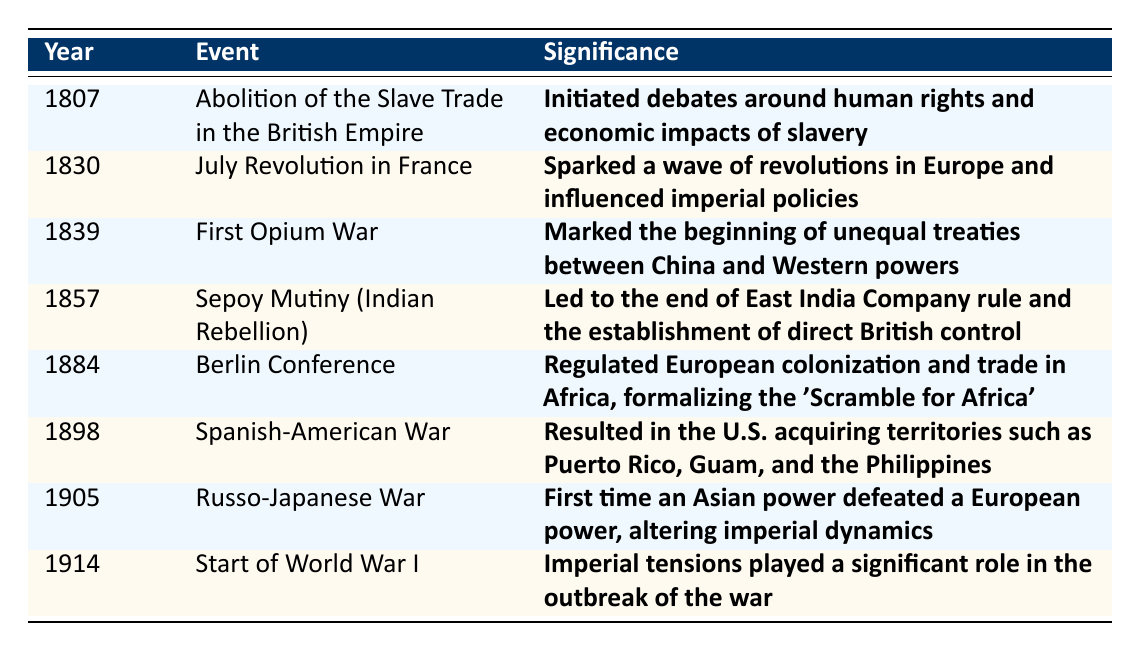What year did the Abolition of the Slave Trade in the British Empire occur? The table explicitly states that the event occurred in 1807. Therefore, the answer is simply the year listed next to the event.
Answer: 1807 Which event happened closest to the year 1900? By inspecting the years listed in the table, the event closest to 1900 is the Spanish-American War, which occurred in 1898.
Answer: Spanish-American War What was the significance of the Berlin Conference? The significance of the Berlin Conference is detailed in the table as regulating European colonization and trade in Africa, formalizing the 'Scramble for Africa'.
Answer: Regulated European colonization and trade in Africa, formalizing the 'Scramble for Africa' How many events listed occurred before 1850? To find this, count the number of events whose years are less than 1850. The events in 1807, 1830, 1839, and 1857 fit this criterion, totaling 4 events.
Answer: 4 Is the statement true that the Russo-Japanese War marked an Asian power defeating a European power? The table mentions this specifically in the significance of the Russo-Japanese War, confirming that it is indeed true that an Asian power defeated a European power during this conflict.
Answer: True What was the first event listed in the table, and what was its significance? The first event listed is the Abolition of the Slave Trade in the British Empire, and its significance is that it initiated debates around human rights and the economic impacts of slavery.
Answer: Abolition of the Slave Trade; initiated debates around human rights and economic impacts of slavery Did any of the events lead to an end of colonial rule in the areas involved? The Sepoy Mutiny is specifically noted in the significance as leading to the end of East India Company rule, resulting in direct British control. Thus, this event is one that led to a change in colonial rule.
Answer: Yes What is the chronological order of events from the earliest to the latest based on the table? To answer this question, look at the years listed in the table in ascending order, which goes: 1807, 1830, 1839, 1857, 1884, 1898, 1905, 1914.
Answer: 1807, 1830, 1839, 1857, 1884, 1898, 1905, 1914 Which two events are mentioned to have significant impacts on imperial policies or dynamics? The July Revolution in France and the Russo-Japanese War are both indicated in their significance as having important impacts on imperial policies or dynamics, as stated in their respective significance descriptions.
Answer: July Revolution, Russo-Japanese War How do the conflicts described relate to direct European control of territories? The Sepoy Mutiny led to the establishment of direct British control, and the First Opium War marked the beginning of unequal treaties, both demonstrating European strategies to maintain or establish control over territories.
Answer: They illustrate direct European control tactics 